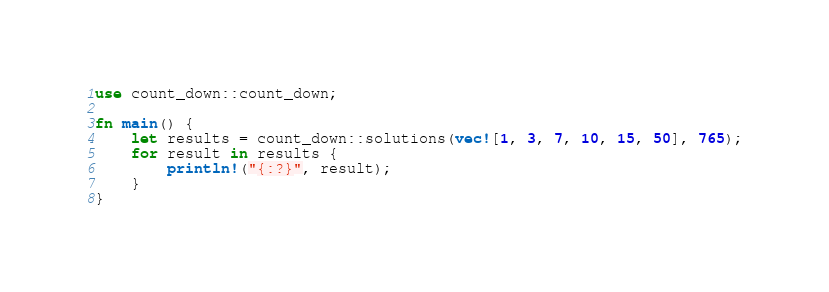<code> <loc_0><loc_0><loc_500><loc_500><_Rust_>use count_down::count_down;

fn main() {
    let results = count_down::solutions(vec![1, 3, 7, 10, 15, 50], 765);
    for result in results {
        println!("{:?}", result);
    }
}
</code> 